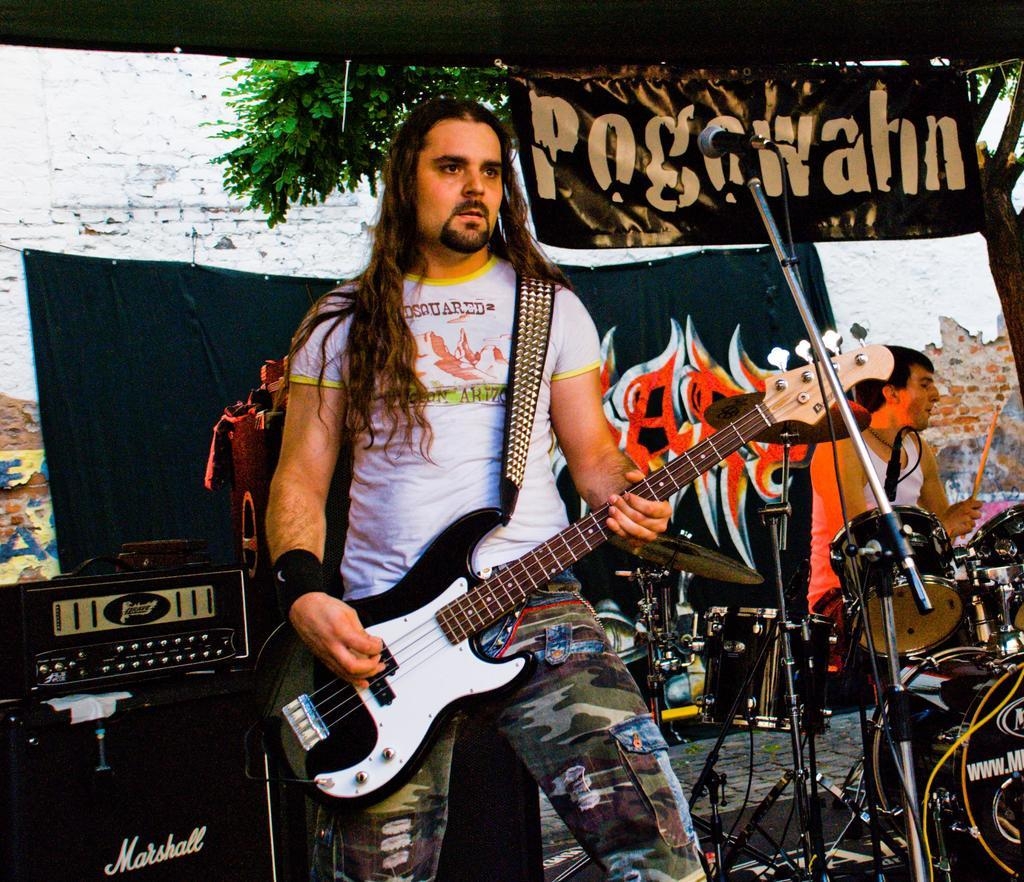What is the man in the image holding? The man is holding a guitar. What part of the man's body is visible in the image? The man's hand is visible in the image. What other musical instrument can be seen in the image? There is a man playing drums in the image. How is the drummer positioned in relation to the viewer? The drummer is positioned with his back to the viewer. What additional object is present in the image? There is a microphone in the image. Is there any text or signage visible in the image? Yes, there is a banner visible in the image. Can you see an owl perched on the guitar in the image? No, there is no owl present in the image. 